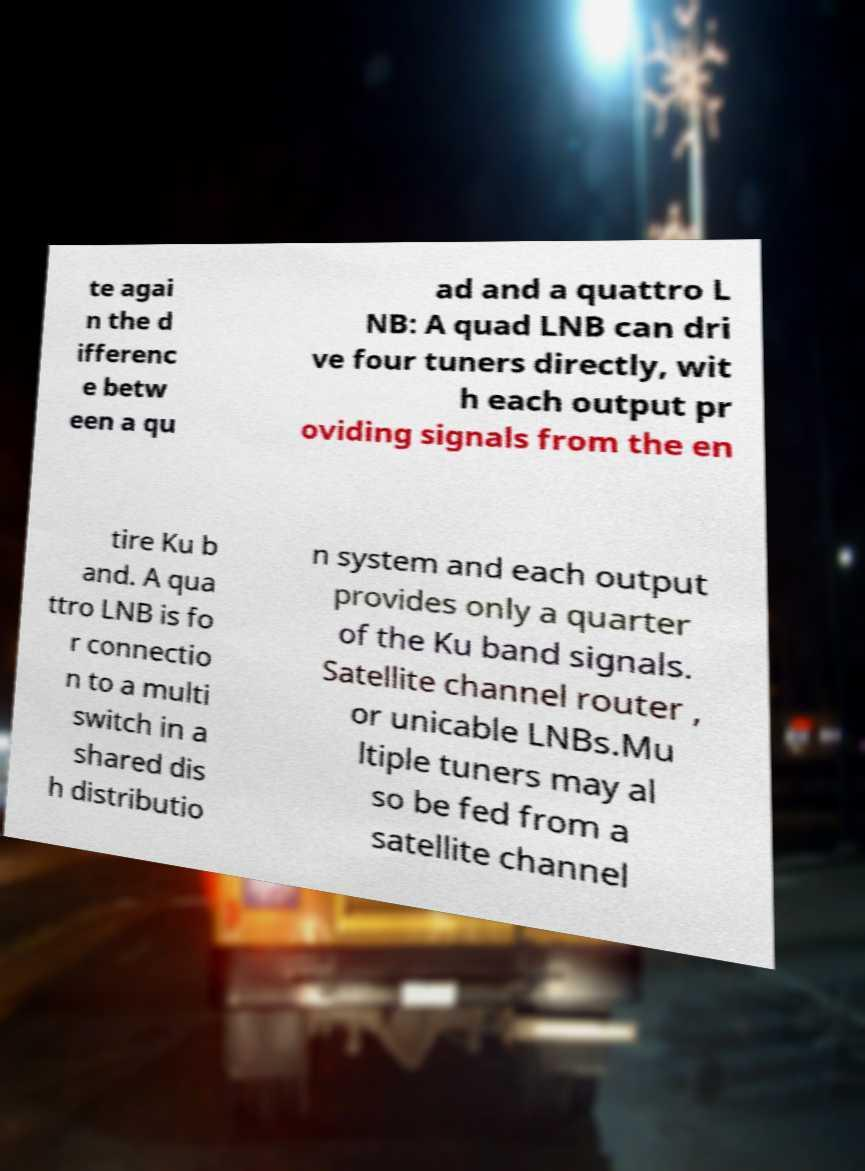For documentation purposes, I need the text within this image transcribed. Could you provide that? te agai n the d ifferenc e betw een a qu ad and a quattro L NB: A quad LNB can dri ve four tuners directly, wit h each output pr oviding signals from the en tire Ku b and. A qua ttro LNB is fo r connectio n to a multi switch in a shared dis h distributio n system and each output provides only a quarter of the Ku band signals. Satellite channel router , or unicable LNBs.Mu ltiple tuners may al so be fed from a satellite channel 